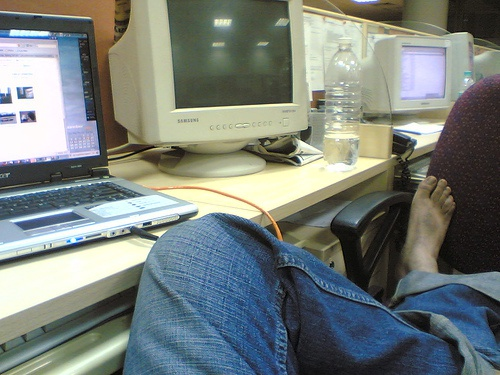Describe the objects in this image and their specific colors. I can see people in olive, blue, black, and gray tones, laptop in olive, white, black, darkgray, and blue tones, tv in olive, gray, beige, darkgreen, and darkgray tones, chair in olive, black, and gray tones, and tv in olive, darkgray, lavender, and lightgray tones in this image. 